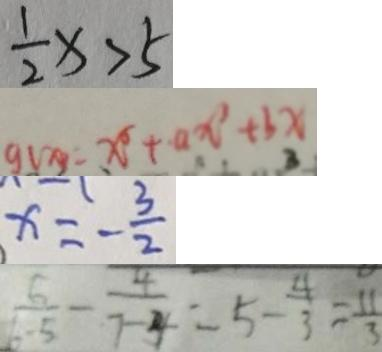Convert formula to latex. <formula><loc_0><loc_0><loc_500><loc_500>\frac { 1 } { 2 } x > 5 
 g ( x ) = x ^ { 5 } + a x ^ { 3 } + b x 
 x = - \frac { 3 } { 2 } 
 \frac { 6 } { 6 - 5 } - \frac { 4 } { 7 - 4 } = 5 - \frac { 4 } { 3 } = \frac { 1 1 } { 3 }</formula> 